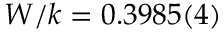<formula> <loc_0><loc_0><loc_500><loc_500>W / k = 0 . 3 9 8 5 ( 4 )</formula> 